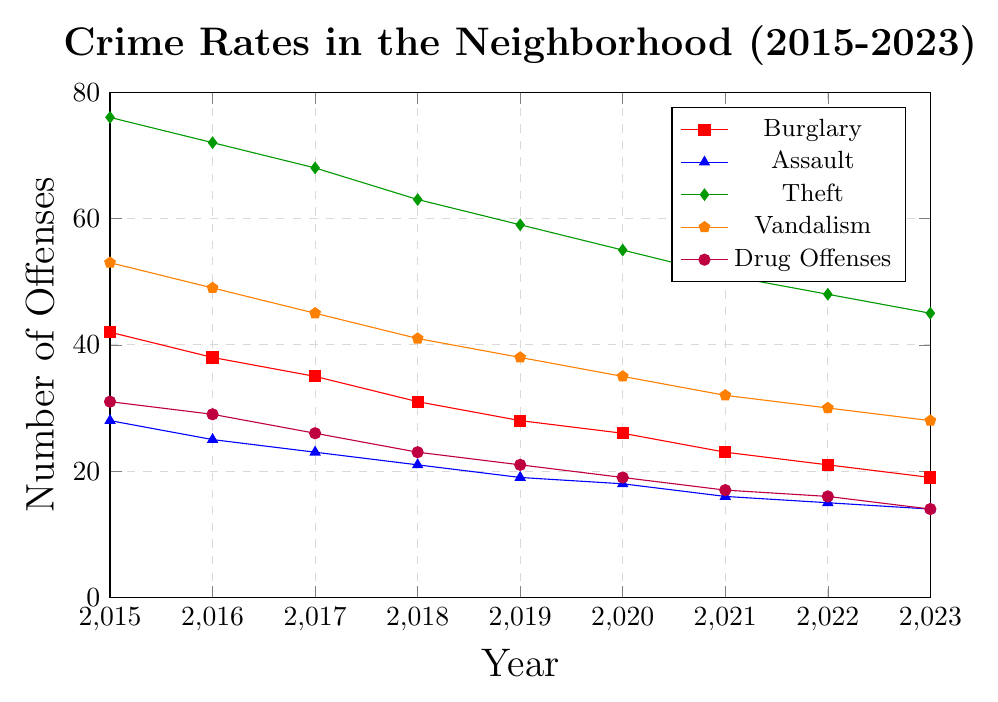What's the trend of Burglary rates from 2015 to 2023? Observing the line representing Burglary rates shows a consistent downward trend from 42 offenses in 2015 to 19 offenses in 2023, indicating a decrease over time.
Answer: Consistent decrease In which year was the highest number of Assault offenses recorded? The highest point on the Assault offense line is in 2015, which corresponds to 28 offenses.
Answer: 2015 How does the trend of Drug Offenses compare to the trend of Vandalism? Both lines show a decrease over time from 2015 to 2023. However, Vandalism shows a higher initial rate and a steeper descent compared to Drug Offenses.
Answer: Similar trend, but different rates Which type of offense had the smallest reduction from 2015 to 2023? To find the smallest reduction, we subtract the 2023 value from the 2015 value for each offense. The smallest difference is in Assault: 28 - 14 = 14.
Answer: Assault What's the average number of Theft offenses from 2015 to 2023? Sum the number of Theft offenses for each year: 76 + 72 + 68 + 63 + 59 + 55 + 51 + 48 + 45 = 537. Divide by the number of years (9): 537 / 9 = 59.67.
Answer: 59.67 Which offense had the second highest value in 2022? Looking at the values for 2022, the highest is Theft with 48, and the second highest is Vandalism with 30.
Answer: Vandalism By how much did Vandalism decrease from 2018 to 2023? Subtract the value in 2023 (28) from the value in 2018 (41): 41 - 28 = 13.
Answer: 13 Which year had the biggest decrease in Burglary offenses compared to the previous year? Calculate the yearly changes: 
2016: 42 - 38 = 4, 2017: 38 - 35 = 3, 2018: 35 - 31 = 4, 2019: 31 - 28 = 3, 2020: 28 - 26 = 2, 2021: 26 - 23 = 3, 2022: 23 - 21 = 2, 2023: 21 - 19 = 2.
The biggest decrease is between 2015 and 2016 with a change of 4 offenses.
Answer: 2016 If the trends continue, predict the number of Theft offenses in 2024. Observing that Theft offenses decrease by roughly 3 to 4 each year, taking an average decrease of 3.5 as a rough estimate: 
2023 value (45) - 3.5 = 41.5, rounded to the nearest whole number.
Answer: 42 